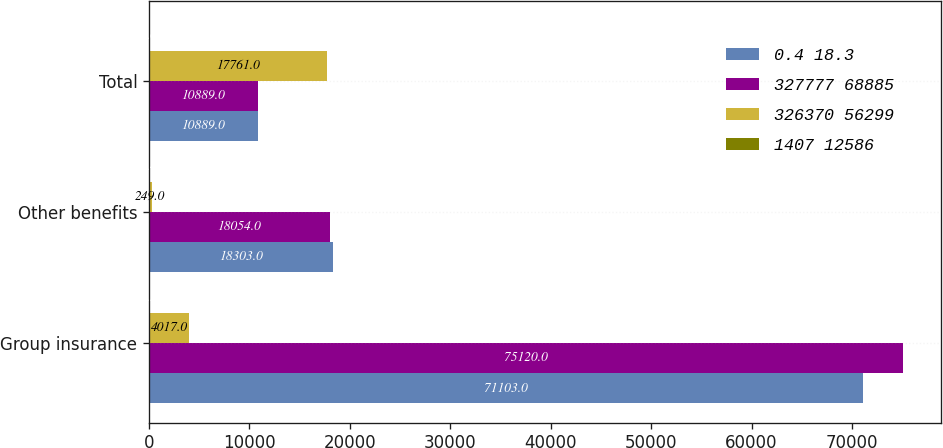Convert chart to OTSL. <chart><loc_0><loc_0><loc_500><loc_500><stacked_bar_chart><ecel><fcel>Group insurance<fcel>Other benefits<fcel>Total<nl><fcel>0.4 18.3<fcel>71103<fcel>18303<fcel>10889<nl><fcel>327777 68885<fcel>75120<fcel>18054<fcel>10889<nl><fcel>326370 56299<fcel>4017<fcel>249<fcel>17761<nl><fcel>1407 12586<fcel>5.3<fcel>1.4<fcel>3.6<nl></chart> 